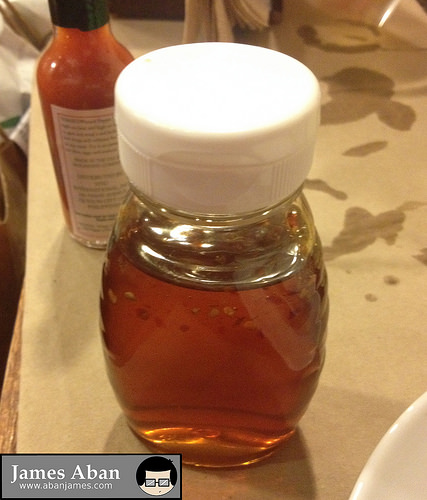<image>
Can you confirm if the paper towels is under the honey? Yes. The paper towels is positioned underneath the honey, with the honey above it in the vertical space. 